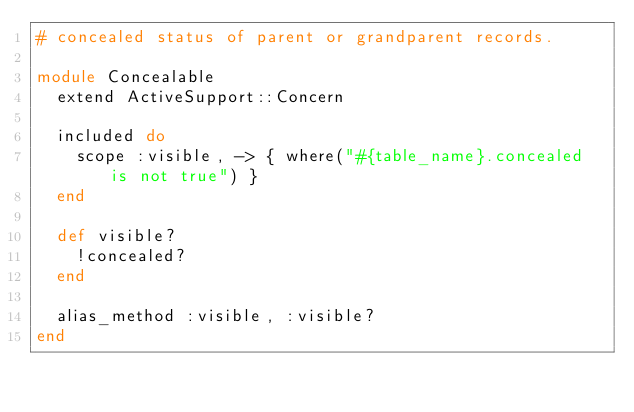<code> <loc_0><loc_0><loc_500><loc_500><_Ruby_># concealed status of parent or grandparent records.

module Concealable
  extend ActiveSupport::Concern

  included do
    scope :visible, -> { where("#{table_name}.concealed is not true") }
  end

  def visible?
    !concealed?
  end

  alias_method :visible, :visible?
end
</code> 